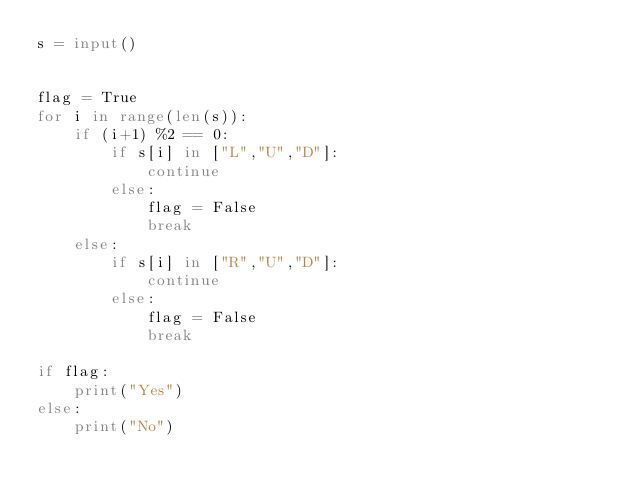<code> <loc_0><loc_0><loc_500><loc_500><_Python_>s = input()


flag = True
for i in range(len(s)):
    if (i+1) %2 == 0:
        if s[i] in ["L","U","D"]:
            continue
        else:
            flag = False
            break
    else:
        if s[i] in ["R","U","D"]:
            continue
        else:
            flag = False
            break

if flag:
    print("Yes")
else:
    print("No")</code> 